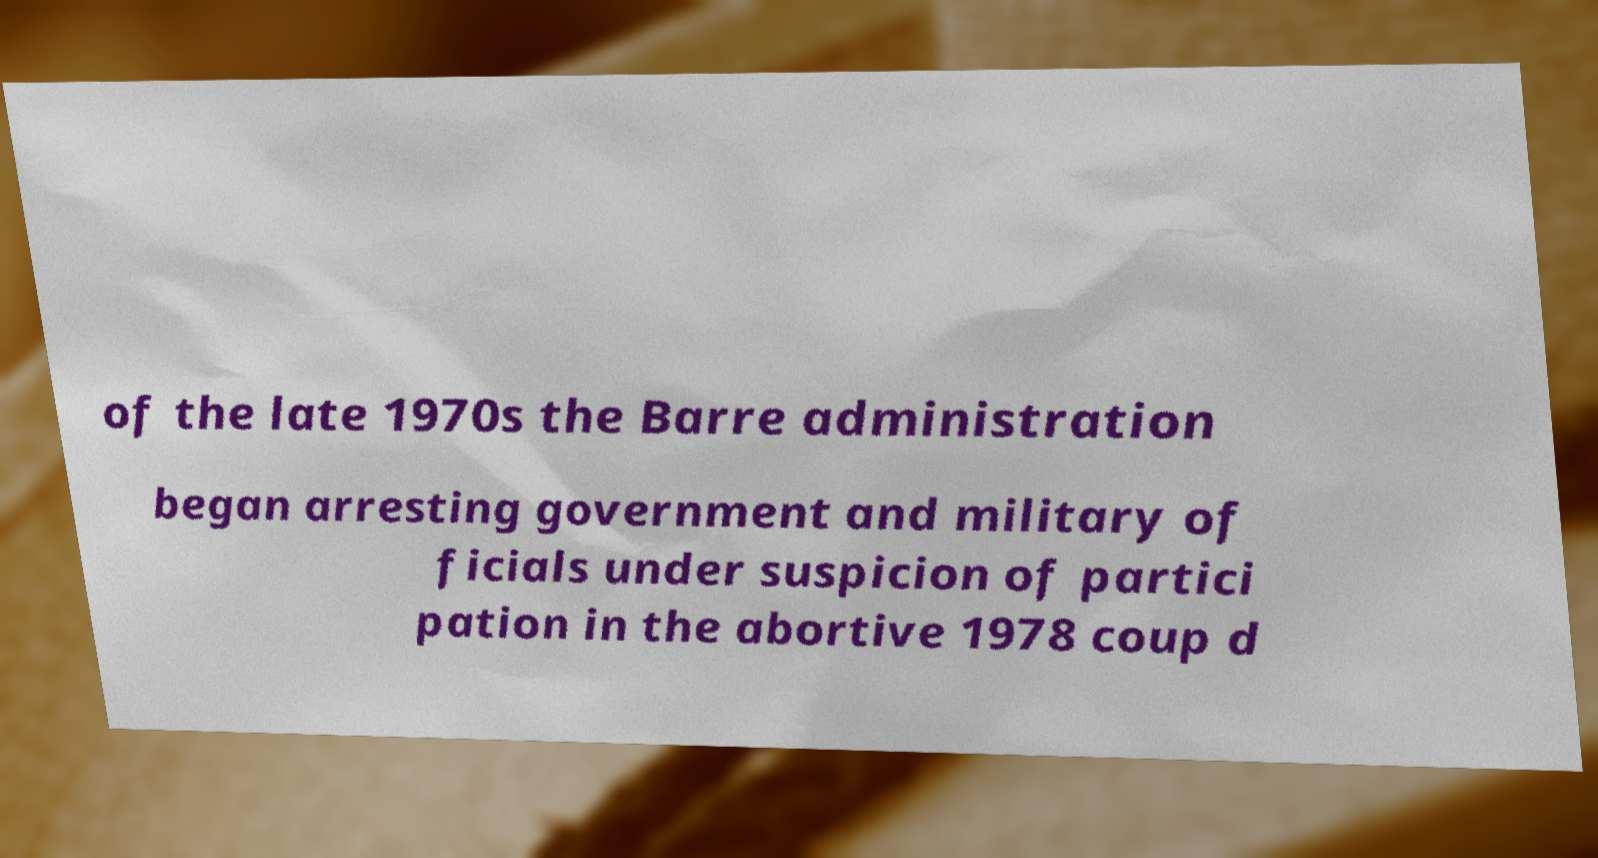Could you assist in decoding the text presented in this image and type it out clearly? of the late 1970s the Barre administration began arresting government and military of ficials under suspicion of partici pation in the abortive 1978 coup d 